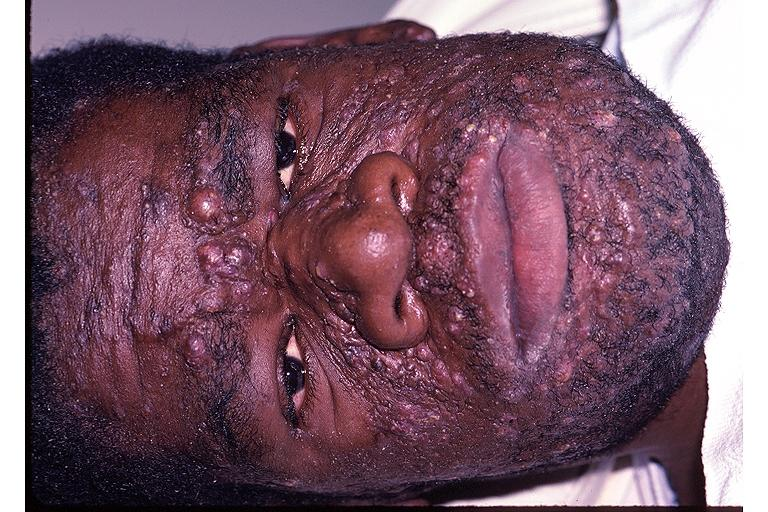does this image show neurofibromatosis?
Answer the question using a single word or phrase. Yes 